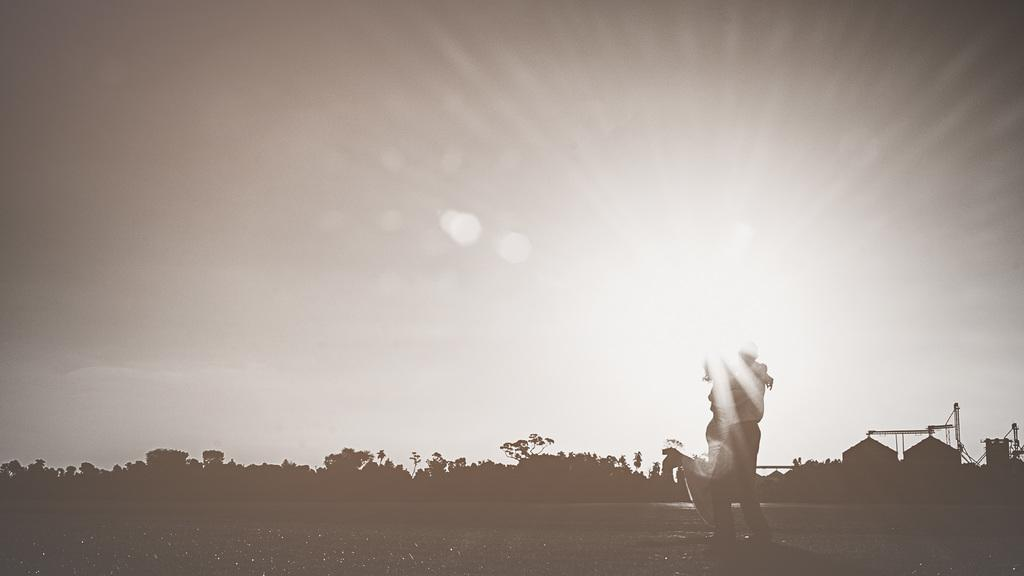What type of image is present in the picture? There is a black and white photograph in the image. Who or what is depicted in the photograph? The photograph contains a man and a woman. What are the man and woman doing in the photograph? The man and woman are holding each other. What can be seen in the background of the photograph? There are many trees visible in the background of the image. What type of powder is being used by the goat in the image? There is no goat present in the image, and therefore no powder or related activity can be observed. 